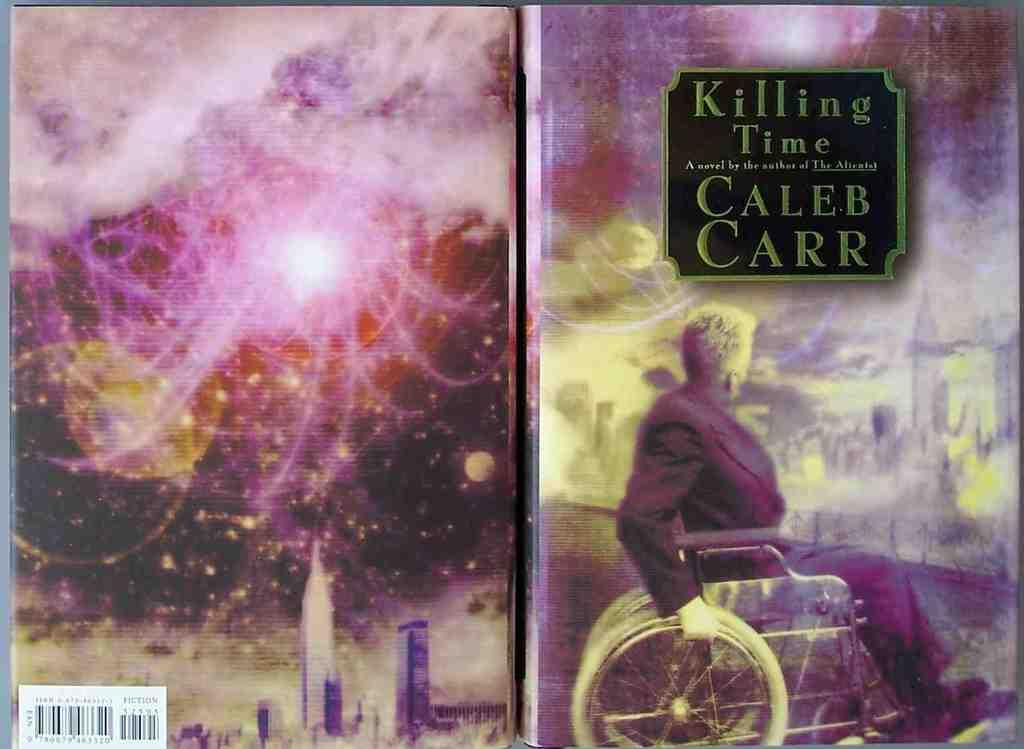<image>
Provide a brief description of the given image. A book entitled Killing Time was written by Caleb Carr. 